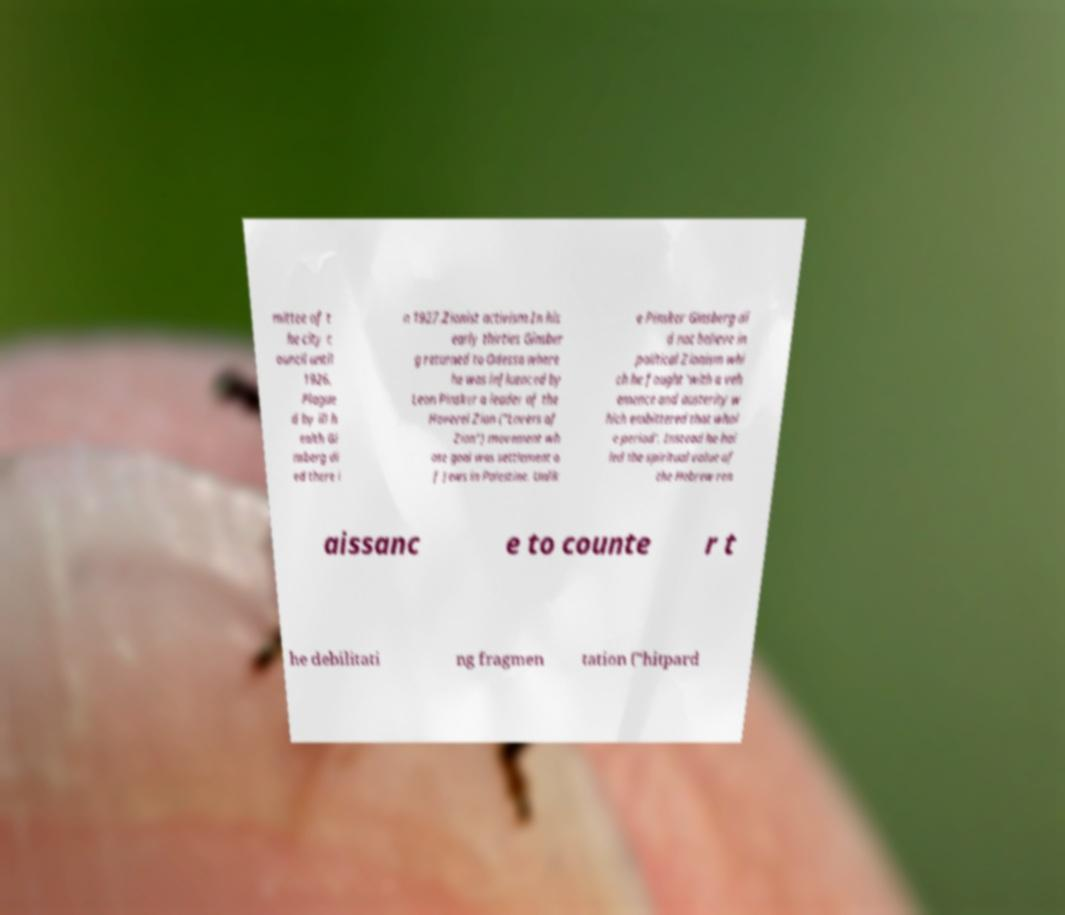I need the written content from this picture converted into text. Can you do that? mittee of t he city c ouncil until 1926. Plague d by ill h ealth Gi nsberg di ed there i n 1927.Zionist activism.In his early thirties Ginsber g returned to Odessa where he was influenced by Leon Pinsker a leader of the Hovevei Zion ("Lovers of Zion") movement wh ose goal was settlement o f Jews in Palestine. Unlik e Pinsker Ginsberg di d not believe in political Zionism whi ch he fought 'with a veh emence and austerity w hich embittered that whol e period'. Instead he hai led the spiritual value of the Hebrew ren aissanc e to counte r t he debilitati ng fragmen tation ("hitpard 